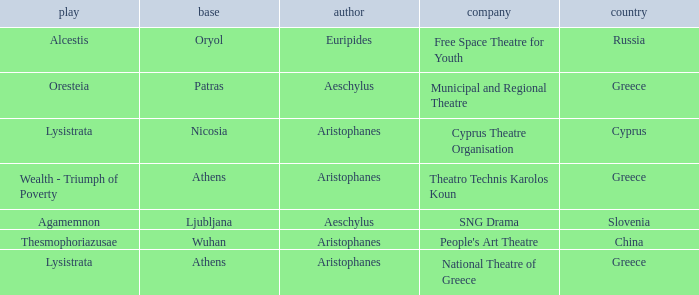What is the play when the company is cyprus theatre organisation? Lysistrata. 